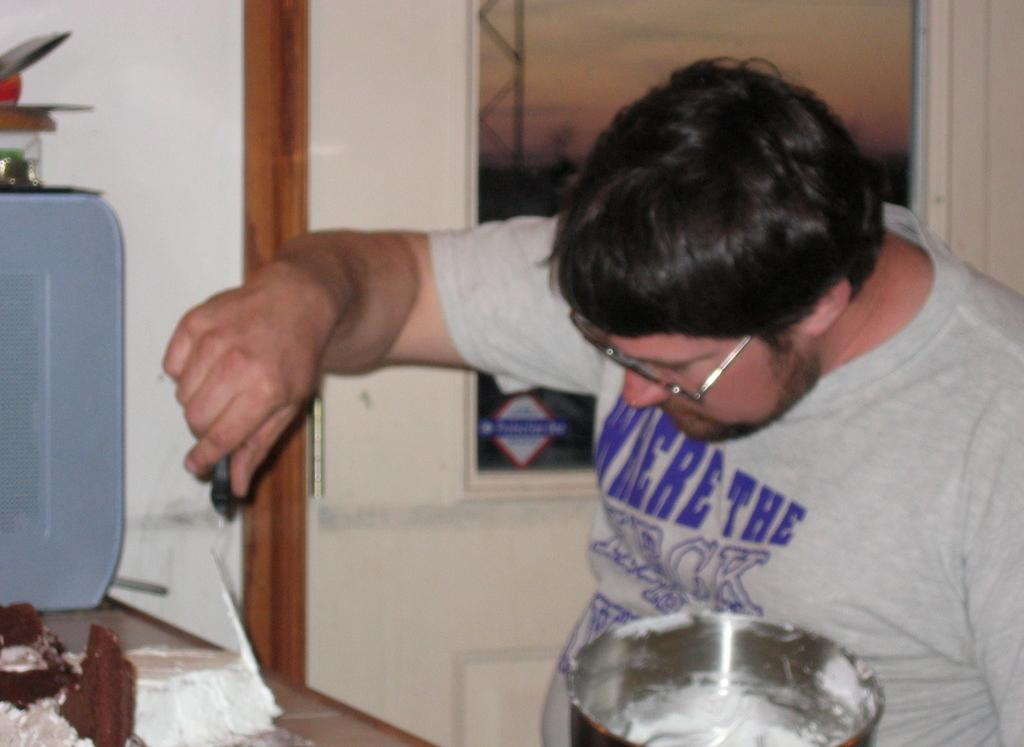Provide a one-sentence caption for the provided image. Man wearing glasses and the shirt there says Where the heck. 